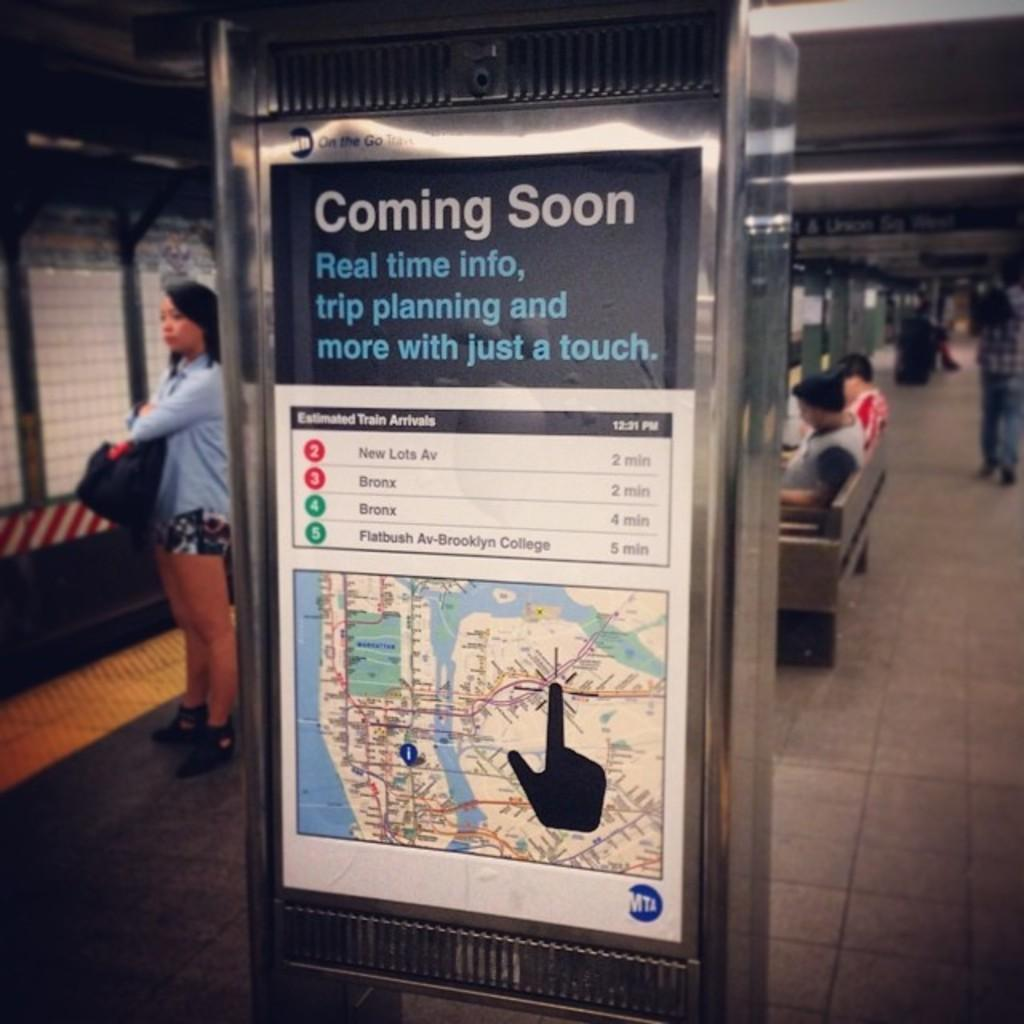<image>
Present a compact description of the photo's key features. A sign at a subway station is informing passengers about a new app by MTA allowing passengers to know about real time info. 